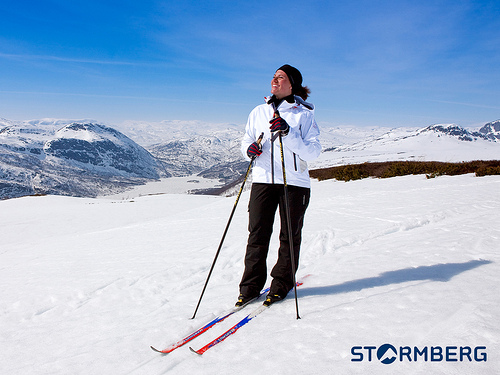Identify and read out the text in this image. STORMBERG 